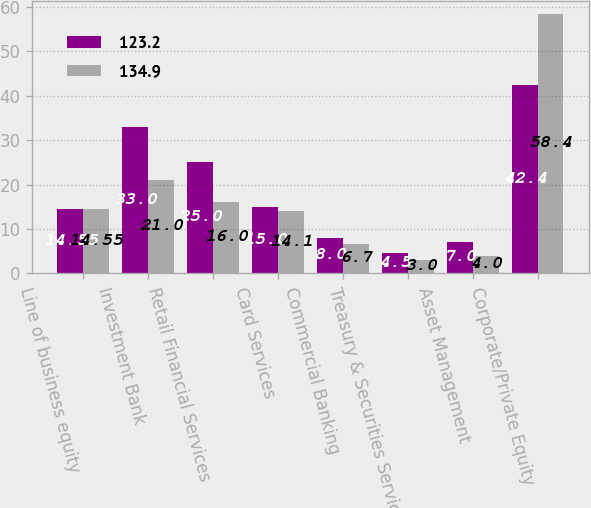<chart> <loc_0><loc_0><loc_500><loc_500><stacked_bar_chart><ecel><fcel>Line of business equity<fcel>Investment Bank<fcel>Retail Financial Services<fcel>Card Services<fcel>Commercial Banking<fcel>Treasury & Securities Services<fcel>Asset Management<fcel>Corporate/Private Equity<nl><fcel>123.2<fcel>14.55<fcel>33<fcel>25<fcel>15<fcel>8<fcel>4.5<fcel>7<fcel>42.4<nl><fcel>134.9<fcel>14.55<fcel>21<fcel>16<fcel>14.1<fcel>6.7<fcel>3<fcel>4<fcel>58.4<nl></chart> 